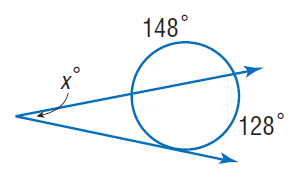Answer the mathemtical geometry problem and directly provide the correct option letter.
Question: Find x.
Choices: A: 22 B: 64 C: 128 D: 148 A 